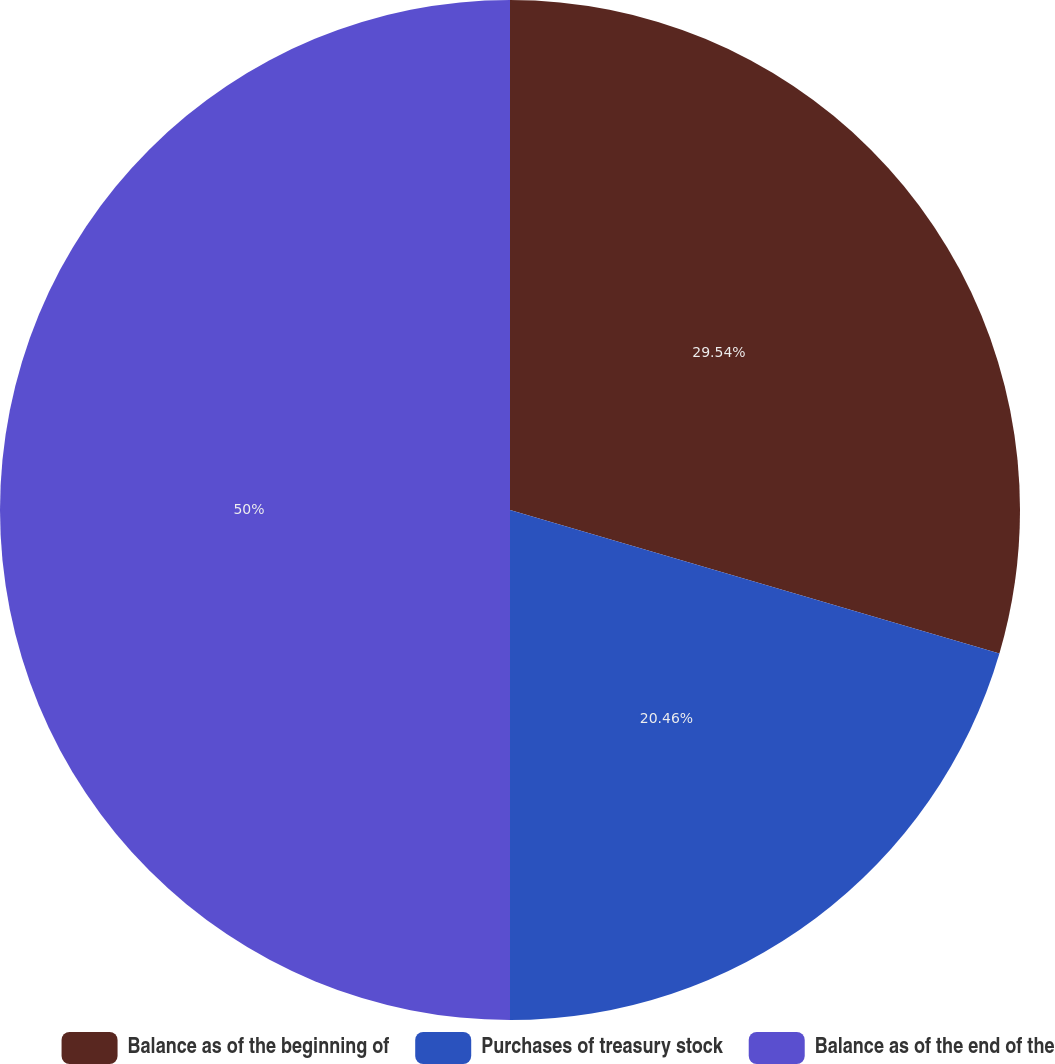Convert chart. <chart><loc_0><loc_0><loc_500><loc_500><pie_chart><fcel>Balance as of the beginning of<fcel>Purchases of treasury stock<fcel>Balance as of the end of the<nl><fcel>29.54%<fcel>20.46%<fcel>50.0%<nl></chart> 